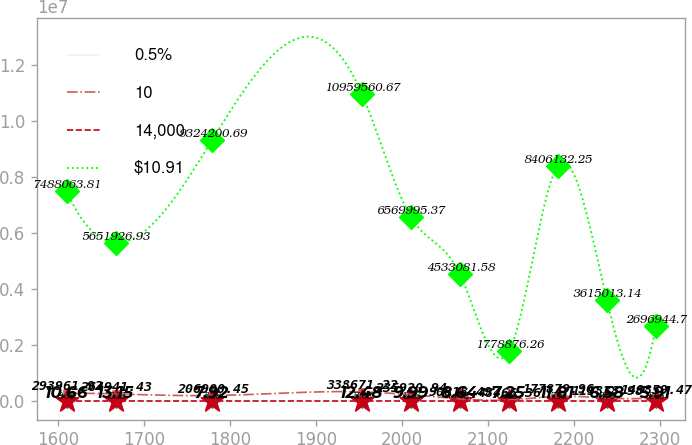<chart> <loc_0><loc_0><loc_500><loc_500><line_chart><ecel><fcel>0.5%<fcel>10<fcel>14,000<fcel>$10.91<nl><fcel>1610.2<fcel>10.66<fcel>293962<fcel>9.08<fcel>7.48806e+06<nl><fcel>1667.13<fcel>13.15<fcel>264941<fcel>10.23<fcel>5.65193e+06<nl><fcel>1779.5<fcel>7.92<fcel>206900<fcel>11.38<fcel>9.3242e+06<nl><fcel>1953.61<fcel>12.48<fcel>338671<fcel>13.68<fcel>1.09596e+07<nl><fcel>2010.54<fcel>9.99<fcel>235921<fcel>12.53<fcel>6.57e+06<nl><fcel>2067.47<fcel>8.64<fcel>90818.5<fcel>4.48<fcel>4.53308e+06<nl><fcel>2124.4<fcel>7.25<fcel>48466.4<fcel>1.66<fcel>1.77888e+06<nl><fcel>2181.33<fcel>11.81<fcel>177880<fcel>7.93<fcel>8.40613e+06<nl><fcel>2238.26<fcel>6.58<fcel>119839<fcel>6.78<fcel>3.61501e+06<nl><fcel>2295.19<fcel>5.91<fcel>148859<fcel>5.63<fcel>2.69694e+06<nl></chart> 